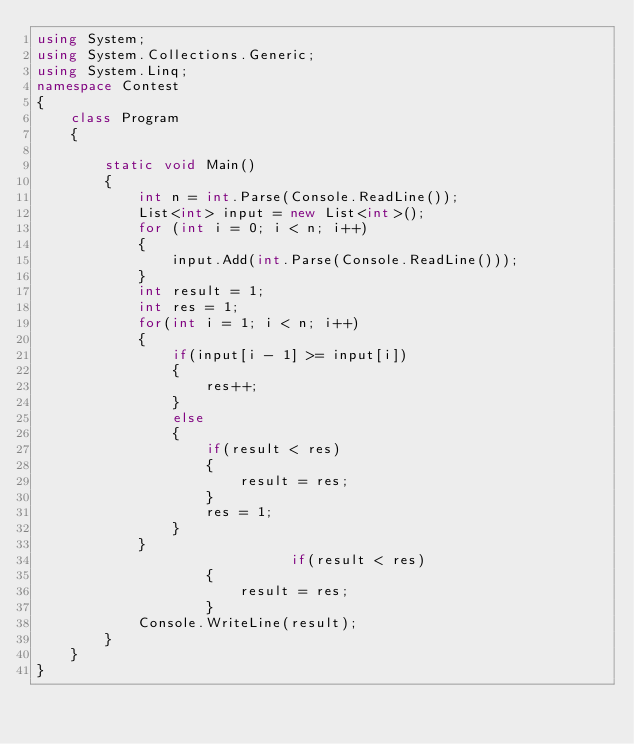Convert code to text. <code><loc_0><loc_0><loc_500><loc_500><_C#_>using System;
using System.Collections.Generic;
using System.Linq;
namespace Contest
{
    class Program
    {

        static void Main()
        {
            int n = int.Parse(Console.ReadLine());
            List<int> input = new List<int>();
            for (int i = 0; i < n; i++)
            {
                input.Add(int.Parse(Console.ReadLine()));
            }
            int result = 1;
            int res = 1;
            for(int i = 1; i < n; i++)
            {
                if(input[i - 1] >= input[i])
                {
                    res++;
                }
                else
                {
                    if(result < res)
                    {
                        result = res;
                    }
                    res = 1;
                }
            }
                              if(result < res)
                    {
                        result = res;
                    }
            Console.WriteLine(result);
        }
    }
}
</code> 